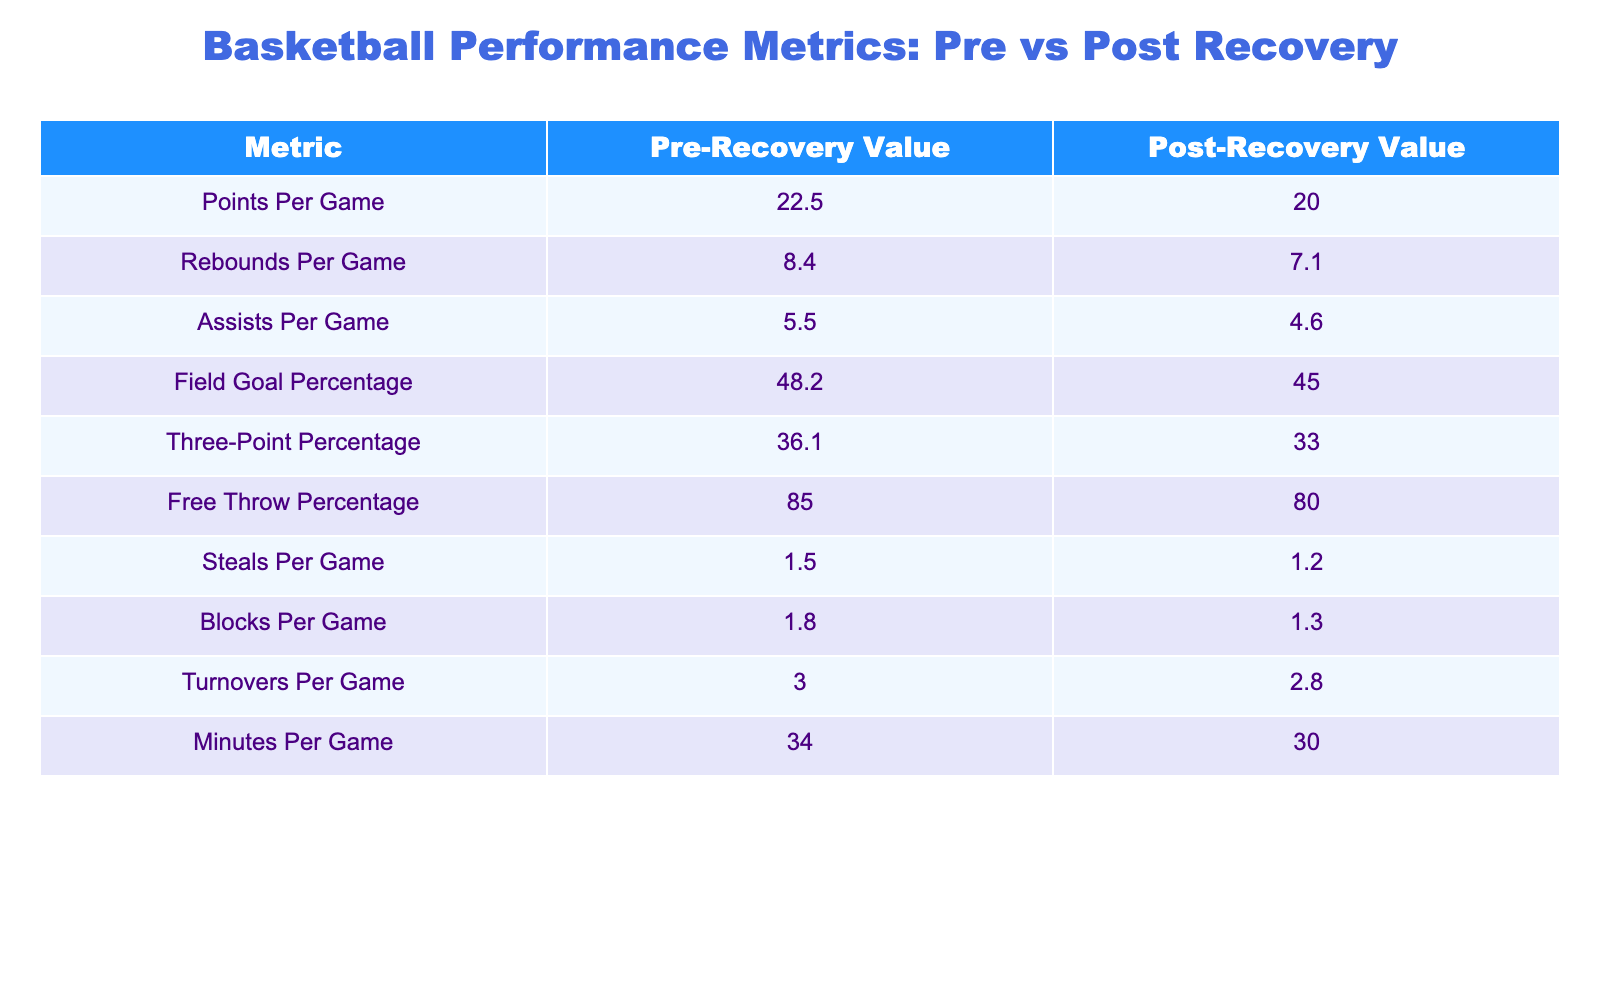What was the Free Throw Percentage before recovery? The table shows the Free Throw Percentage under the "Pre-Recovery Value" column, which is listed as 85.0.
Answer: 85.0 What is the difference in Points Per Game before and after recovery? To find the difference, subtract the Post-Recovery Value of 20.0 from the Pre-Recovery Value of 22.5: 22.5 - 20.0 = 2.5.
Answer: 2.5 Did the player have a higher Field Goal Percentage before recovery than after? The Pre-Recovery Value for Field Goal Percentage is 48.2, while the Post-Recovery Value is 45.0. Since 48.2 is greater than 45.0, the answer is yes.
Answer: Yes What are the average Rebounds and Assists Per Game before recovery? To find the average, add the Rebounds Per Game (8.4) and Assists Per Game (5.5) and divide by 2: (8.4 + 5.5) / 2 = 6.95.
Answer: 6.95 How many metrics saw a decrease in value after recovery? By examining the table, the metrics that decreased are Points Per Game, Rebounds Per Game, Assists Per Game, Field Goal Percentage, Three-Point Percentage, Free Throw Percentage, Steals Per Game, and Blocks Per Game. There are 8 metrics that decreased.
Answer: 8 Was the average Minutes Per Game higher or lower after recovery? The Pre-Recovery Minutes Per Game is 34.0, and the Post-Recovery Minutes Per Game is 30.0. Since 34.0 is greater than 30.0, the average is lower after recovery.
Answer: Lower What is the total of Turnovers Per Game and Steals Per Game before recovery? To find the total, add Turnovers Per Game (3.0) and Steals Per Game (1.5): 3.0 + 1.5 = 4.5.
Answer: 4.5 Is the difference in Three-Point Percentage greater than the difference in Free Throw Percentage? The difference in Three-Point Percentage is 36.1 - 33.0 = 3.1, and the difference in Free Throw Percentage is 85.0 - 80.0 = 5.0. Since 5.0 is greater than 3.1, the answer is no.
Answer: No 